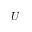<formula> <loc_0><loc_0><loc_500><loc_500>U</formula> 